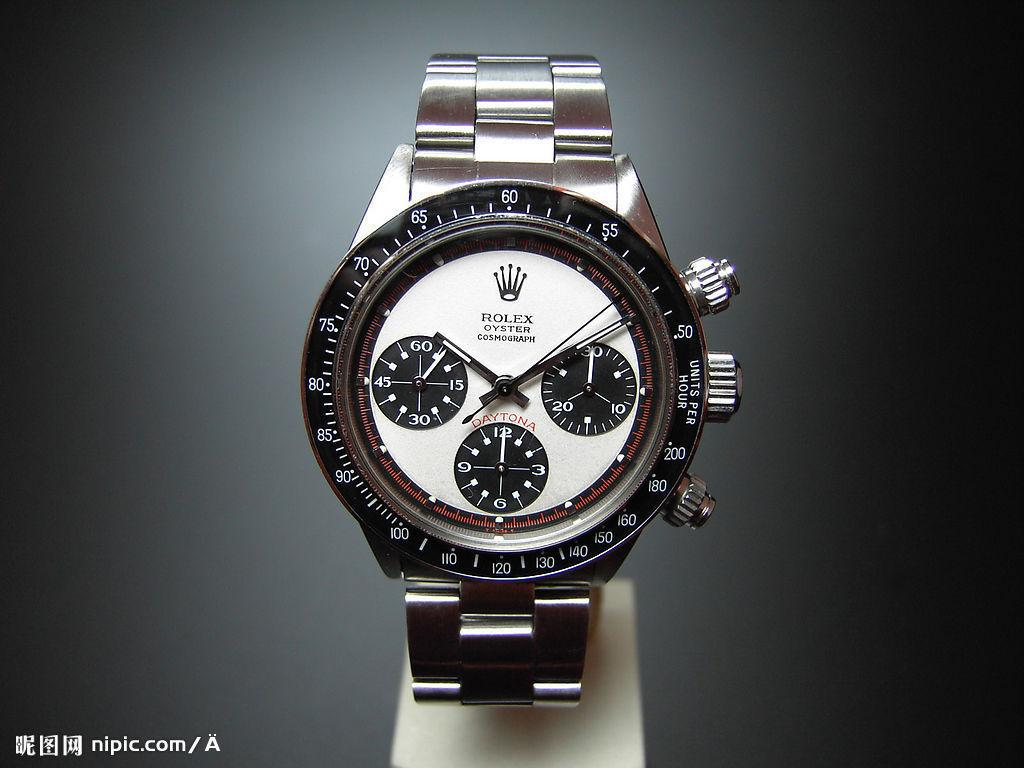Provide a one-sentence caption for the provided image. A silver Rolex oyster watch with a white face is displayed on a stand. 